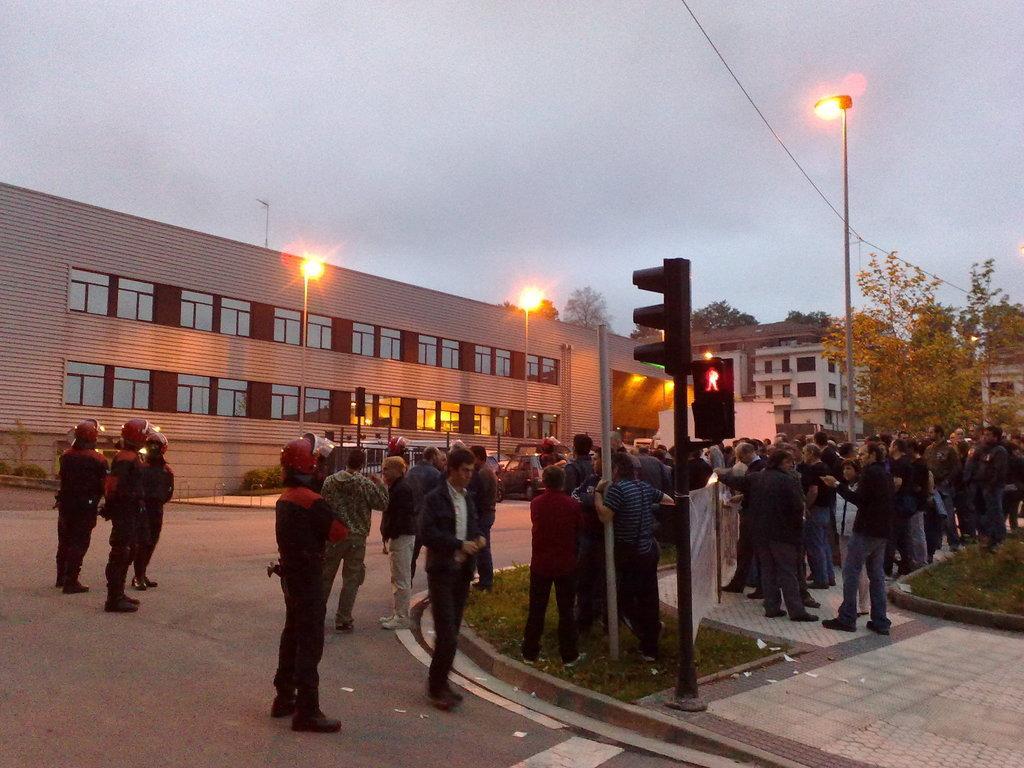How would you summarize this image in a sentence or two? This is the picture of a city. In this image there are group of people standing on the road and on the footpath. At the back there are buildings and trees an there are street lights on the footpath. At the top there is sky. At the bottom there is a road and there is grass. 